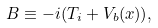<formula> <loc_0><loc_0><loc_500><loc_500>B \equiv - i ( T _ { i } + V _ { b } ( x ) ) ,</formula> 